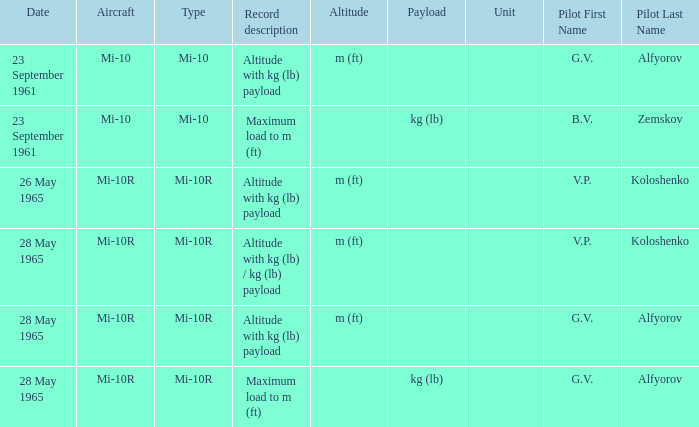Pilot of g.v. alfyorov, and a Record description of altitude with kg (lb) payload, and a Type of mi-10 involved what date? 23 September 1961. 